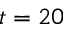<formula> <loc_0><loc_0><loc_500><loc_500>t = 2 0</formula> 